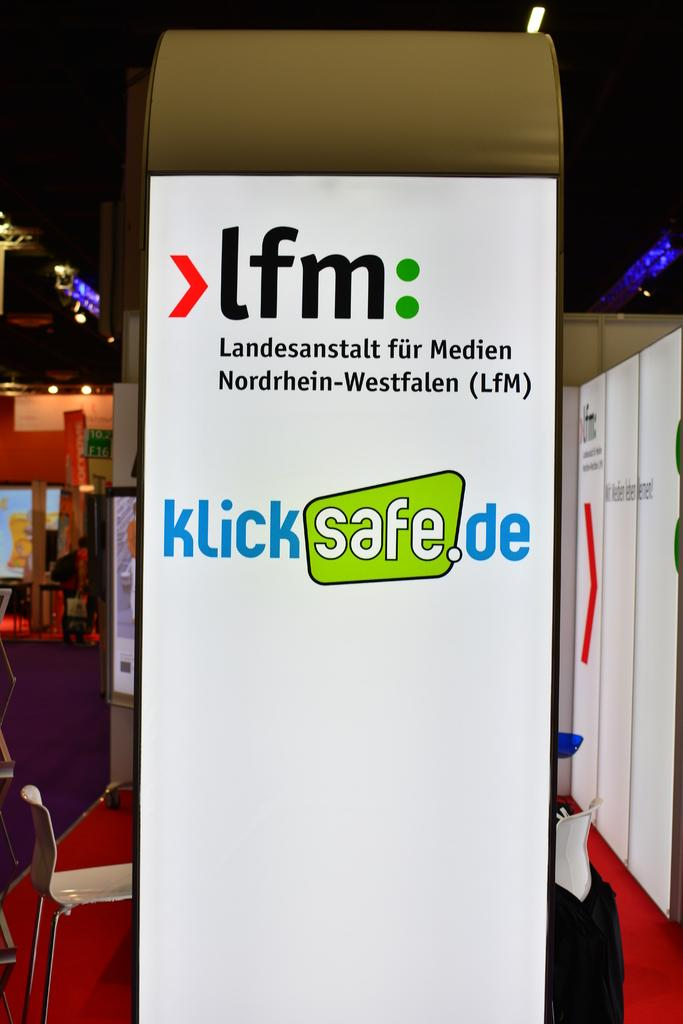Provide a one-sentence caption for the provided image. A display stand at a conference is in German and is an advert for klicksafe.de. 